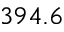Convert formula to latex. <formula><loc_0><loc_0><loc_500><loc_500>3 9 4 . 6</formula> 